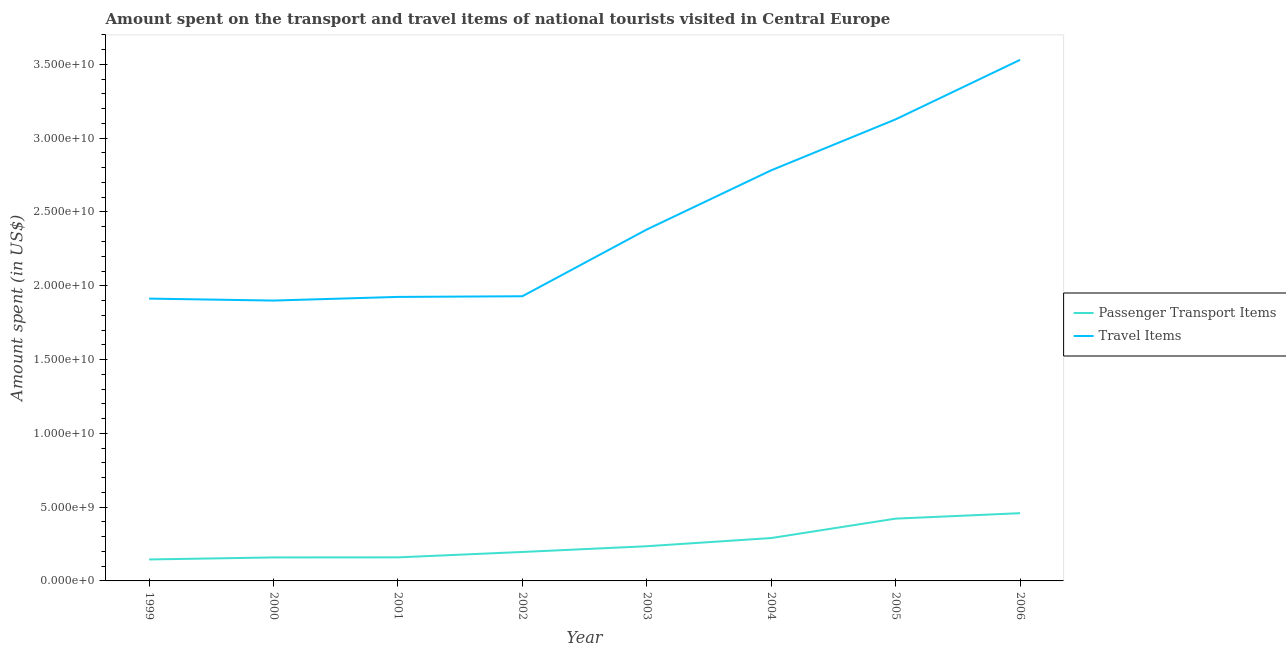How many different coloured lines are there?
Give a very brief answer. 2. Is the number of lines equal to the number of legend labels?
Offer a terse response. Yes. What is the amount spent on passenger transport items in 2005?
Your response must be concise. 4.22e+09. Across all years, what is the maximum amount spent on passenger transport items?
Give a very brief answer. 4.59e+09. Across all years, what is the minimum amount spent on passenger transport items?
Offer a terse response. 1.45e+09. In which year was the amount spent on passenger transport items maximum?
Your response must be concise. 2006. What is the total amount spent on passenger transport items in the graph?
Provide a succinct answer. 2.07e+1. What is the difference between the amount spent on passenger transport items in 2004 and that in 2006?
Provide a succinct answer. -1.68e+09. What is the difference between the amount spent in travel items in 2005 and the amount spent on passenger transport items in 2001?
Provide a succinct answer. 2.97e+1. What is the average amount spent on passenger transport items per year?
Make the answer very short. 2.58e+09. In the year 2000, what is the difference between the amount spent on passenger transport items and amount spent in travel items?
Your answer should be very brief. -1.74e+1. What is the ratio of the amount spent in travel items in 1999 to that in 2003?
Your answer should be very brief. 0.8. Is the amount spent on passenger transport items in 1999 less than that in 2005?
Provide a short and direct response. Yes. Is the difference between the amount spent on passenger transport items in 1999 and 2005 greater than the difference between the amount spent in travel items in 1999 and 2005?
Your answer should be compact. Yes. What is the difference between the highest and the second highest amount spent in travel items?
Your response must be concise. 4.03e+09. What is the difference between the highest and the lowest amount spent on passenger transport items?
Ensure brevity in your answer.  3.14e+09. Is the amount spent in travel items strictly greater than the amount spent on passenger transport items over the years?
Your response must be concise. Yes. Is the amount spent on passenger transport items strictly less than the amount spent in travel items over the years?
Ensure brevity in your answer.  Yes. How many years are there in the graph?
Make the answer very short. 8. Are the values on the major ticks of Y-axis written in scientific E-notation?
Your response must be concise. Yes. How are the legend labels stacked?
Keep it short and to the point. Vertical. What is the title of the graph?
Ensure brevity in your answer.  Amount spent on the transport and travel items of national tourists visited in Central Europe. Does "Female population" appear as one of the legend labels in the graph?
Give a very brief answer. No. What is the label or title of the Y-axis?
Give a very brief answer. Amount spent (in US$). What is the Amount spent (in US$) of Passenger Transport Items in 1999?
Offer a terse response. 1.45e+09. What is the Amount spent (in US$) in Travel Items in 1999?
Provide a short and direct response. 1.91e+1. What is the Amount spent (in US$) of Passenger Transport Items in 2000?
Your response must be concise. 1.59e+09. What is the Amount spent (in US$) of Travel Items in 2000?
Provide a short and direct response. 1.90e+1. What is the Amount spent (in US$) in Passenger Transport Items in 2001?
Offer a very short reply. 1.60e+09. What is the Amount spent (in US$) in Travel Items in 2001?
Your answer should be very brief. 1.92e+1. What is the Amount spent (in US$) in Passenger Transport Items in 2002?
Give a very brief answer. 1.96e+09. What is the Amount spent (in US$) in Travel Items in 2002?
Provide a succinct answer. 1.93e+1. What is the Amount spent (in US$) of Passenger Transport Items in 2003?
Give a very brief answer. 2.35e+09. What is the Amount spent (in US$) of Travel Items in 2003?
Your answer should be compact. 2.38e+1. What is the Amount spent (in US$) of Passenger Transport Items in 2004?
Your response must be concise. 2.91e+09. What is the Amount spent (in US$) in Travel Items in 2004?
Ensure brevity in your answer.  2.78e+1. What is the Amount spent (in US$) of Passenger Transport Items in 2005?
Your response must be concise. 4.22e+09. What is the Amount spent (in US$) of Travel Items in 2005?
Make the answer very short. 3.13e+1. What is the Amount spent (in US$) of Passenger Transport Items in 2006?
Keep it short and to the point. 4.59e+09. What is the Amount spent (in US$) in Travel Items in 2006?
Your response must be concise. 3.53e+1. Across all years, what is the maximum Amount spent (in US$) in Passenger Transport Items?
Offer a terse response. 4.59e+09. Across all years, what is the maximum Amount spent (in US$) of Travel Items?
Give a very brief answer. 3.53e+1. Across all years, what is the minimum Amount spent (in US$) of Passenger Transport Items?
Provide a succinct answer. 1.45e+09. Across all years, what is the minimum Amount spent (in US$) in Travel Items?
Make the answer very short. 1.90e+1. What is the total Amount spent (in US$) of Passenger Transport Items in the graph?
Your answer should be very brief. 2.07e+1. What is the total Amount spent (in US$) in Travel Items in the graph?
Offer a terse response. 1.95e+11. What is the difference between the Amount spent (in US$) of Passenger Transport Items in 1999 and that in 2000?
Your response must be concise. -1.37e+08. What is the difference between the Amount spent (in US$) in Travel Items in 1999 and that in 2000?
Your answer should be very brief. 1.33e+08. What is the difference between the Amount spent (in US$) in Passenger Transport Items in 1999 and that in 2001?
Ensure brevity in your answer.  -1.42e+08. What is the difference between the Amount spent (in US$) in Travel Items in 1999 and that in 2001?
Your answer should be compact. -1.15e+08. What is the difference between the Amount spent (in US$) of Passenger Transport Items in 1999 and that in 2002?
Keep it short and to the point. -5.08e+08. What is the difference between the Amount spent (in US$) in Travel Items in 1999 and that in 2002?
Offer a terse response. -1.60e+08. What is the difference between the Amount spent (in US$) in Passenger Transport Items in 1999 and that in 2003?
Offer a very short reply. -8.97e+08. What is the difference between the Amount spent (in US$) in Travel Items in 1999 and that in 2003?
Offer a very short reply. -4.68e+09. What is the difference between the Amount spent (in US$) in Passenger Transport Items in 1999 and that in 2004?
Give a very brief answer. -1.45e+09. What is the difference between the Amount spent (in US$) in Travel Items in 1999 and that in 2004?
Provide a short and direct response. -8.69e+09. What is the difference between the Amount spent (in US$) of Passenger Transport Items in 1999 and that in 2005?
Ensure brevity in your answer.  -2.77e+09. What is the difference between the Amount spent (in US$) of Travel Items in 1999 and that in 2005?
Keep it short and to the point. -1.21e+1. What is the difference between the Amount spent (in US$) in Passenger Transport Items in 1999 and that in 2006?
Your answer should be very brief. -3.14e+09. What is the difference between the Amount spent (in US$) of Travel Items in 1999 and that in 2006?
Make the answer very short. -1.62e+1. What is the difference between the Amount spent (in US$) of Passenger Transport Items in 2000 and that in 2001?
Provide a short and direct response. -5.06e+06. What is the difference between the Amount spent (in US$) of Travel Items in 2000 and that in 2001?
Provide a short and direct response. -2.48e+08. What is the difference between the Amount spent (in US$) in Passenger Transport Items in 2000 and that in 2002?
Your response must be concise. -3.71e+08. What is the difference between the Amount spent (in US$) in Travel Items in 2000 and that in 2002?
Keep it short and to the point. -2.93e+08. What is the difference between the Amount spent (in US$) of Passenger Transport Items in 2000 and that in 2003?
Your answer should be compact. -7.60e+08. What is the difference between the Amount spent (in US$) of Travel Items in 2000 and that in 2003?
Provide a short and direct response. -4.82e+09. What is the difference between the Amount spent (in US$) of Passenger Transport Items in 2000 and that in 2004?
Ensure brevity in your answer.  -1.31e+09. What is the difference between the Amount spent (in US$) of Travel Items in 2000 and that in 2004?
Provide a short and direct response. -8.83e+09. What is the difference between the Amount spent (in US$) in Passenger Transport Items in 2000 and that in 2005?
Provide a short and direct response. -2.63e+09. What is the difference between the Amount spent (in US$) in Travel Items in 2000 and that in 2005?
Your answer should be compact. -1.23e+1. What is the difference between the Amount spent (in US$) in Passenger Transport Items in 2000 and that in 2006?
Provide a succinct answer. -3.00e+09. What is the difference between the Amount spent (in US$) of Travel Items in 2000 and that in 2006?
Offer a very short reply. -1.63e+1. What is the difference between the Amount spent (in US$) in Passenger Transport Items in 2001 and that in 2002?
Offer a terse response. -3.66e+08. What is the difference between the Amount spent (in US$) of Travel Items in 2001 and that in 2002?
Your response must be concise. -4.50e+07. What is the difference between the Amount spent (in US$) of Passenger Transport Items in 2001 and that in 2003?
Your response must be concise. -7.55e+08. What is the difference between the Amount spent (in US$) in Travel Items in 2001 and that in 2003?
Keep it short and to the point. -4.57e+09. What is the difference between the Amount spent (in US$) in Passenger Transport Items in 2001 and that in 2004?
Provide a succinct answer. -1.31e+09. What is the difference between the Amount spent (in US$) of Travel Items in 2001 and that in 2004?
Keep it short and to the point. -8.58e+09. What is the difference between the Amount spent (in US$) in Passenger Transport Items in 2001 and that in 2005?
Give a very brief answer. -2.62e+09. What is the difference between the Amount spent (in US$) of Travel Items in 2001 and that in 2005?
Your response must be concise. -1.20e+1. What is the difference between the Amount spent (in US$) in Passenger Transport Items in 2001 and that in 2006?
Your answer should be compact. -2.99e+09. What is the difference between the Amount spent (in US$) in Travel Items in 2001 and that in 2006?
Provide a short and direct response. -1.61e+1. What is the difference between the Amount spent (in US$) of Passenger Transport Items in 2002 and that in 2003?
Offer a terse response. -3.89e+08. What is the difference between the Amount spent (in US$) in Travel Items in 2002 and that in 2003?
Your answer should be very brief. -4.52e+09. What is the difference between the Amount spent (in US$) of Passenger Transport Items in 2002 and that in 2004?
Your answer should be very brief. -9.44e+08. What is the difference between the Amount spent (in US$) in Travel Items in 2002 and that in 2004?
Offer a very short reply. -8.53e+09. What is the difference between the Amount spent (in US$) of Passenger Transport Items in 2002 and that in 2005?
Give a very brief answer. -2.26e+09. What is the difference between the Amount spent (in US$) of Travel Items in 2002 and that in 2005?
Offer a very short reply. -1.20e+1. What is the difference between the Amount spent (in US$) in Passenger Transport Items in 2002 and that in 2006?
Your response must be concise. -2.63e+09. What is the difference between the Amount spent (in US$) of Travel Items in 2002 and that in 2006?
Your answer should be very brief. -1.60e+1. What is the difference between the Amount spent (in US$) of Passenger Transport Items in 2003 and that in 2004?
Your response must be concise. -5.55e+08. What is the difference between the Amount spent (in US$) of Travel Items in 2003 and that in 2004?
Provide a short and direct response. -4.01e+09. What is the difference between the Amount spent (in US$) in Passenger Transport Items in 2003 and that in 2005?
Your answer should be compact. -1.87e+09. What is the difference between the Amount spent (in US$) in Travel Items in 2003 and that in 2005?
Provide a succinct answer. -7.46e+09. What is the difference between the Amount spent (in US$) in Passenger Transport Items in 2003 and that in 2006?
Offer a very short reply. -2.24e+09. What is the difference between the Amount spent (in US$) in Travel Items in 2003 and that in 2006?
Give a very brief answer. -1.15e+1. What is the difference between the Amount spent (in US$) in Passenger Transport Items in 2004 and that in 2005?
Offer a very short reply. -1.32e+09. What is the difference between the Amount spent (in US$) in Travel Items in 2004 and that in 2005?
Keep it short and to the point. -3.45e+09. What is the difference between the Amount spent (in US$) in Passenger Transport Items in 2004 and that in 2006?
Give a very brief answer. -1.68e+09. What is the difference between the Amount spent (in US$) of Travel Items in 2004 and that in 2006?
Provide a succinct answer. -7.48e+09. What is the difference between the Amount spent (in US$) of Passenger Transport Items in 2005 and that in 2006?
Your answer should be very brief. -3.69e+08. What is the difference between the Amount spent (in US$) in Travel Items in 2005 and that in 2006?
Keep it short and to the point. -4.03e+09. What is the difference between the Amount spent (in US$) in Passenger Transport Items in 1999 and the Amount spent (in US$) in Travel Items in 2000?
Keep it short and to the point. -1.75e+1. What is the difference between the Amount spent (in US$) of Passenger Transport Items in 1999 and the Amount spent (in US$) of Travel Items in 2001?
Your response must be concise. -1.78e+1. What is the difference between the Amount spent (in US$) of Passenger Transport Items in 1999 and the Amount spent (in US$) of Travel Items in 2002?
Provide a short and direct response. -1.78e+1. What is the difference between the Amount spent (in US$) in Passenger Transport Items in 1999 and the Amount spent (in US$) in Travel Items in 2003?
Your answer should be very brief. -2.24e+1. What is the difference between the Amount spent (in US$) of Passenger Transport Items in 1999 and the Amount spent (in US$) of Travel Items in 2004?
Your answer should be very brief. -2.64e+1. What is the difference between the Amount spent (in US$) of Passenger Transport Items in 1999 and the Amount spent (in US$) of Travel Items in 2005?
Provide a short and direct response. -2.98e+1. What is the difference between the Amount spent (in US$) in Passenger Transport Items in 1999 and the Amount spent (in US$) in Travel Items in 2006?
Your response must be concise. -3.39e+1. What is the difference between the Amount spent (in US$) of Passenger Transport Items in 2000 and the Amount spent (in US$) of Travel Items in 2001?
Keep it short and to the point. -1.77e+1. What is the difference between the Amount spent (in US$) of Passenger Transport Items in 2000 and the Amount spent (in US$) of Travel Items in 2002?
Give a very brief answer. -1.77e+1. What is the difference between the Amount spent (in US$) in Passenger Transport Items in 2000 and the Amount spent (in US$) in Travel Items in 2003?
Ensure brevity in your answer.  -2.22e+1. What is the difference between the Amount spent (in US$) of Passenger Transport Items in 2000 and the Amount spent (in US$) of Travel Items in 2004?
Offer a terse response. -2.62e+1. What is the difference between the Amount spent (in US$) of Passenger Transport Items in 2000 and the Amount spent (in US$) of Travel Items in 2005?
Keep it short and to the point. -2.97e+1. What is the difference between the Amount spent (in US$) of Passenger Transport Items in 2000 and the Amount spent (in US$) of Travel Items in 2006?
Keep it short and to the point. -3.37e+1. What is the difference between the Amount spent (in US$) of Passenger Transport Items in 2001 and the Amount spent (in US$) of Travel Items in 2002?
Ensure brevity in your answer.  -1.77e+1. What is the difference between the Amount spent (in US$) of Passenger Transport Items in 2001 and the Amount spent (in US$) of Travel Items in 2003?
Provide a short and direct response. -2.22e+1. What is the difference between the Amount spent (in US$) of Passenger Transport Items in 2001 and the Amount spent (in US$) of Travel Items in 2004?
Offer a very short reply. -2.62e+1. What is the difference between the Amount spent (in US$) of Passenger Transport Items in 2001 and the Amount spent (in US$) of Travel Items in 2005?
Provide a succinct answer. -2.97e+1. What is the difference between the Amount spent (in US$) in Passenger Transport Items in 2001 and the Amount spent (in US$) in Travel Items in 2006?
Your answer should be very brief. -3.37e+1. What is the difference between the Amount spent (in US$) of Passenger Transport Items in 2002 and the Amount spent (in US$) of Travel Items in 2003?
Provide a short and direct response. -2.19e+1. What is the difference between the Amount spent (in US$) of Passenger Transport Items in 2002 and the Amount spent (in US$) of Travel Items in 2004?
Offer a terse response. -2.59e+1. What is the difference between the Amount spent (in US$) in Passenger Transport Items in 2002 and the Amount spent (in US$) in Travel Items in 2005?
Offer a terse response. -2.93e+1. What is the difference between the Amount spent (in US$) in Passenger Transport Items in 2002 and the Amount spent (in US$) in Travel Items in 2006?
Your response must be concise. -3.33e+1. What is the difference between the Amount spent (in US$) of Passenger Transport Items in 2003 and the Amount spent (in US$) of Travel Items in 2004?
Your answer should be compact. -2.55e+1. What is the difference between the Amount spent (in US$) of Passenger Transport Items in 2003 and the Amount spent (in US$) of Travel Items in 2005?
Provide a succinct answer. -2.89e+1. What is the difference between the Amount spent (in US$) in Passenger Transport Items in 2003 and the Amount spent (in US$) in Travel Items in 2006?
Ensure brevity in your answer.  -3.30e+1. What is the difference between the Amount spent (in US$) of Passenger Transport Items in 2004 and the Amount spent (in US$) of Travel Items in 2005?
Provide a short and direct response. -2.84e+1. What is the difference between the Amount spent (in US$) in Passenger Transport Items in 2004 and the Amount spent (in US$) in Travel Items in 2006?
Offer a terse response. -3.24e+1. What is the difference between the Amount spent (in US$) of Passenger Transport Items in 2005 and the Amount spent (in US$) of Travel Items in 2006?
Your response must be concise. -3.11e+1. What is the average Amount spent (in US$) of Passenger Transport Items per year?
Your answer should be very brief. 2.58e+09. What is the average Amount spent (in US$) in Travel Items per year?
Offer a terse response. 2.44e+1. In the year 1999, what is the difference between the Amount spent (in US$) in Passenger Transport Items and Amount spent (in US$) in Travel Items?
Your answer should be very brief. -1.77e+1. In the year 2000, what is the difference between the Amount spent (in US$) of Passenger Transport Items and Amount spent (in US$) of Travel Items?
Give a very brief answer. -1.74e+1. In the year 2001, what is the difference between the Amount spent (in US$) in Passenger Transport Items and Amount spent (in US$) in Travel Items?
Provide a succinct answer. -1.76e+1. In the year 2002, what is the difference between the Amount spent (in US$) in Passenger Transport Items and Amount spent (in US$) in Travel Items?
Offer a very short reply. -1.73e+1. In the year 2003, what is the difference between the Amount spent (in US$) of Passenger Transport Items and Amount spent (in US$) of Travel Items?
Offer a terse response. -2.15e+1. In the year 2004, what is the difference between the Amount spent (in US$) in Passenger Transport Items and Amount spent (in US$) in Travel Items?
Keep it short and to the point. -2.49e+1. In the year 2005, what is the difference between the Amount spent (in US$) of Passenger Transport Items and Amount spent (in US$) of Travel Items?
Your response must be concise. -2.71e+1. In the year 2006, what is the difference between the Amount spent (in US$) of Passenger Transport Items and Amount spent (in US$) of Travel Items?
Offer a very short reply. -3.07e+1. What is the ratio of the Amount spent (in US$) of Passenger Transport Items in 1999 to that in 2000?
Give a very brief answer. 0.91. What is the ratio of the Amount spent (in US$) of Travel Items in 1999 to that in 2000?
Your response must be concise. 1.01. What is the ratio of the Amount spent (in US$) in Passenger Transport Items in 1999 to that in 2001?
Make the answer very short. 0.91. What is the ratio of the Amount spent (in US$) of Travel Items in 1999 to that in 2001?
Keep it short and to the point. 0.99. What is the ratio of the Amount spent (in US$) of Passenger Transport Items in 1999 to that in 2002?
Your answer should be compact. 0.74. What is the ratio of the Amount spent (in US$) of Travel Items in 1999 to that in 2002?
Offer a very short reply. 0.99. What is the ratio of the Amount spent (in US$) in Passenger Transport Items in 1999 to that in 2003?
Offer a very short reply. 0.62. What is the ratio of the Amount spent (in US$) in Travel Items in 1999 to that in 2003?
Provide a succinct answer. 0.8. What is the ratio of the Amount spent (in US$) in Passenger Transport Items in 1999 to that in 2004?
Your response must be concise. 0.5. What is the ratio of the Amount spent (in US$) in Travel Items in 1999 to that in 2004?
Your answer should be very brief. 0.69. What is the ratio of the Amount spent (in US$) of Passenger Transport Items in 1999 to that in 2005?
Ensure brevity in your answer.  0.34. What is the ratio of the Amount spent (in US$) of Travel Items in 1999 to that in 2005?
Make the answer very short. 0.61. What is the ratio of the Amount spent (in US$) in Passenger Transport Items in 1999 to that in 2006?
Your response must be concise. 0.32. What is the ratio of the Amount spent (in US$) in Travel Items in 1999 to that in 2006?
Provide a short and direct response. 0.54. What is the ratio of the Amount spent (in US$) in Passenger Transport Items in 2000 to that in 2001?
Your response must be concise. 1. What is the ratio of the Amount spent (in US$) of Travel Items in 2000 to that in 2001?
Your response must be concise. 0.99. What is the ratio of the Amount spent (in US$) in Passenger Transport Items in 2000 to that in 2002?
Provide a short and direct response. 0.81. What is the ratio of the Amount spent (in US$) of Passenger Transport Items in 2000 to that in 2003?
Your answer should be very brief. 0.68. What is the ratio of the Amount spent (in US$) of Travel Items in 2000 to that in 2003?
Give a very brief answer. 0.8. What is the ratio of the Amount spent (in US$) in Passenger Transport Items in 2000 to that in 2004?
Provide a succinct answer. 0.55. What is the ratio of the Amount spent (in US$) in Travel Items in 2000 to that in 2004?
Make the answer very short. 0.68. What is the ratio of the Amount spent (in US$) in Passenger Transport Items in 2000 to that in 2005?
Make the answer very short. 0.38. What is the ratio of the Amount spent (in US$) in Travel Items in 2000 to that in 2005?
Your answer should be very brief. 0.61. What is the ratio of the Amount spent (in US$) in Passenger Transport Items in 2000 to that in 2006?
Provide a succinct answer. 0.35. What is the ratio of the Amount spent (in US$) in Travel Items in 2000 to that in 2006?
Your response must be concise. 0.54. What is the ratio of the Amount spent (in US$) in Passenger Transport Items in 2001 to that in 2002?
Offer a terse response. 0.81. What is the ratio of the Amount spent (in US$) of Passenger Transport Items in 2001 to that in 2003?
Offer a terse response. 0.68. What is the ratio of the Amount spent (in US$) in Travel Items in 2001 to that in 2003?
Provide a short and direct response. 0.81. What is the ratio of the Amount spent (in US$) of Passenger Transport Items in 2001 to that in 2004?
Your answer should be very brief. 0.55. What is the ratio of the Amount spent (in US$) of Travel Items in 2001 to that in 2004?
Offer a terse response. 0.69. What is the ratio of the Amount spent (in US$) in Passenger Transport Items in 2001 to that in 2005?
Provide a succinct answer. 0.38. What is the ratio of the Amount spent (in US$) of Travel Items in 2001 to that in 2005?
Provide a succinct answer. 0.62. What is the ratio of the Amount spent (in US$) of Passenger Transport Items in 2001 to that in 2006?
Offer a very short reply. 0.35. What is the ratio of the Amount spent (in US$) of Travel Items in 2001 to that in 2006?
Your response must be concise. 0.55. What is the ratio of the Amount spent (in US$) in Passenger Transport Items in 2002 to that in 2003?
Offer a very short reply. 0.83. What is the ratio of the Amount spent (in US$) in Travel Items in 2002 to that in 2003?
Provide a short and direct response. 0.81. What is the ratio of the Amount spent (in US$) in Passenger Transport Items in 2002 to that in 2004?
Give a very brief answer. 0.68. What is the ratio of the Amount spent (in US$) of Travel Items in 2002 to that in 2004?
Offer a very short reply. 0.69. What is the ratio of the Amount spent (in US$) in Passenger Transport Items in 2002 to that in 2005?
Your answer should be very brief. 0.46. What is the ratio of the Amount spent (in US$) in Travel Items in 2002 to that in 2005?
Your answer should be very brief. 0.62. What is the ratio of the Amount spent (in US$) in Passenger Transport Items in 2002 to that in 2006?
Give a very brief answer. 0.43. What is the ratio of the Amount spent (in US$) of Travel Items in 2002 to that in 2006?
Give a very brief answer. 0.55. What is the ratio of the Amount spent (in US$) in Passenger Transport Items in 2003 to that in 2004?
Make the answer very short. 0.81. What is the ratio of the Amount spent (in US$) in Travel Items in 2003 to that in 2004?
Offer a very short reply. 0.86. What is the ratio of the Amount spent (in US$) in Passenger Transport Items in 2003 to that in 2005?
Offer a very short reply. 0.56. What is the ratio of the Amount spent (in US$) in Travel Items in 2003 to that in 2005?
Offer a terse response. 0.76. What is the ratio of the Amount spent (in US$) of Passenger Transport Items in 2003 to that in 2006?
Your answer should be compact. 0.51. What is the ratio of the Amount spent (in US$) of Travel Items in 2003 to that in 2006?
Make the answer very short. 0.67. What is the ratio of the Amount spent (in US$) in Passenger Transport Items in 2004 to that in 2005?
Your answer should be very brief. 0.69. What is the ratio of the Amount spent (in US$) of Travel Items in 2004 to that in 2005?
Your answer should be very brief. 0.89. What is the ratio of the Amount spent (in US$) in Passenger Transport Items in 2004 to that in 2006?
Make the answer very short. 0.63. What is the ratio of the Amount spent (in US$) in Travel Items in 2004 to that in 2006?
Provide a short and direct response. 0.79. What is the ratio of the Amount spent (in US$) of Passenger Transport Items in 2005 to that in 2006?
Your response must be concise. 0.92. What is the ratio of the Amount spent (in US$) in Travel Items in 2005 to that in 2006?
Your response must be concise. 0.89. What is the difference between the highest and the second highest Amount spent (in US$) in Passenger Transport Items?
Make the answer very short. 3.69e+08. What is the difference between the highest and the second highest Amount spent (in US$) in Travel Items?
Give a very brief answer. 4.03e+09. What is the difference between the highest and the lowest Amount spent (in US$) in Passenger Transport Items?
Your answer should be compact. 3.14e+09. What is the difference between the highest and the lowest Amount spent (in US$) of Travel Items?
Your answer should be very brief. 1.63e+1. 